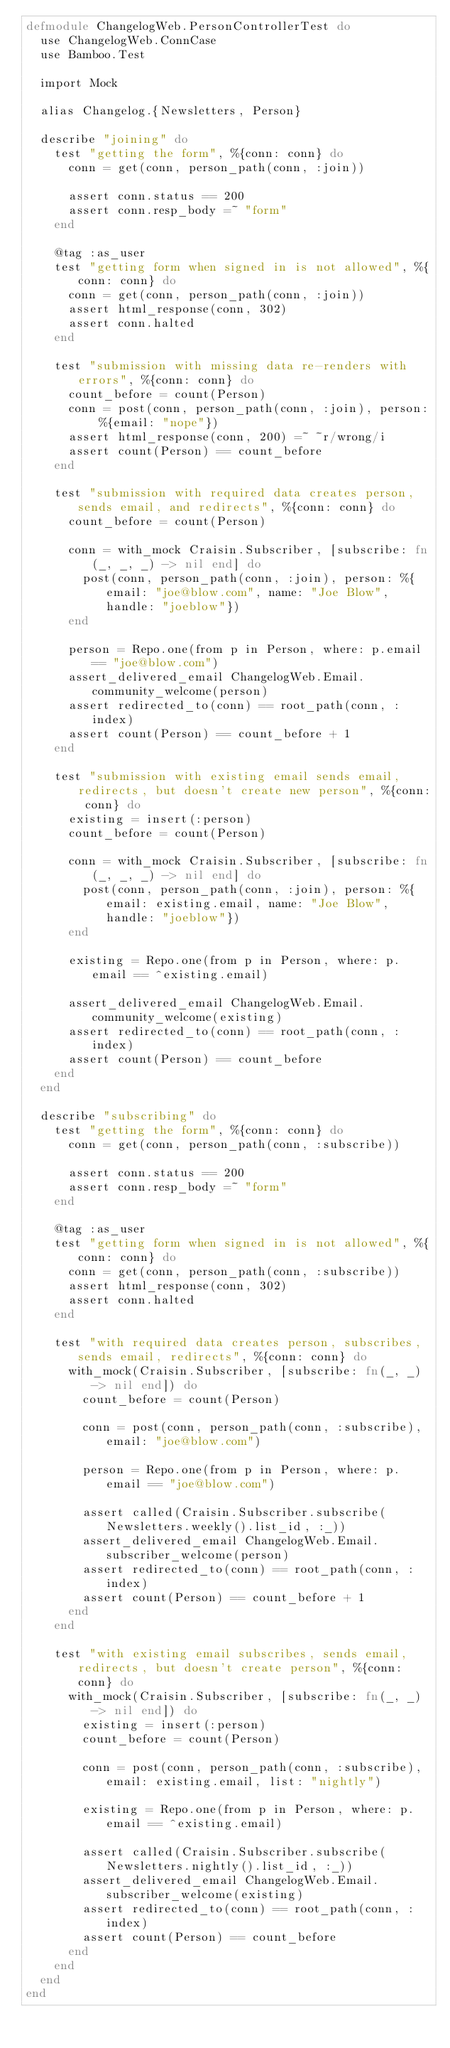<code> <loc_0><loc_0><loc_500><loc_500><_Elixir_>defmodule ChangelogWeb.PersonControllerTest do
  use ChangelogWeb.ConnCase
  use Bamboo.Test

  import Mock

  alias Changelog.{Newsletters, Person}

  describe "joining" do
    test "getting the form", %{conn: conn} do
      conn = get(conn, person_path(conn, :join))

      assert conn.status == 200
      assert conn.resp_body =~ "form"
    end

    @tag :as_user
    test "getting form when signed in is not allowed", %{conn: conn} do
      conn = get(conn, person_path(conn, :join))
      assert html_response(conn, 302)
      assert conn.halted
    end

    test "submission with missing data re-renders with errors", %{conn: conn} do
      count_before = count(Person)
      conn = post(conn, person_path(conn, :join), person: %{email: "nope"})
      assert html_response(conn, 200) =~ ~r/wrong/i
      assert count(Person) == count_before
    end

    test "submission with required data creates person, sends email, and redirects", %{conn: conn} do
      count_before = count(Person)

      conn = with_mock Craisin.Subscriber, [subscribe: fn(_, _, _) -> nil end] do
        post(conn, person_path(conn, :join), person: %{email: "joe@blow.com", name: "Joe Blow", handle: "joeblow"})
      end

      person = Repo.one(from p in Person, where: p.email == "joe@blow.com")
      assert_delivered_email ChangelogWeb.Email.community_welcome(person)
      assert redirected_to(conn) == root_path(conn, :index)
      assert count(Person) == count_before + 1
    end

    test "submission with existing email sends email, redirects, but doesn't create new person", %{conn: conn} do
      existing = insert(:person)
      count_before = count(Person)

      conn = with_mock Craisin.Subscriber, [subscribe: fn(_, _, _) -> nil end] do
        post(conn, person_path(conn, :join), person: %{email: existing.email, name: "Joe Blow", handle: "joeblow"})
      end

      existing = Repo.one(from p in Person, where: p.email == ^existing.email)

      assert_delivered_email ChangelogWeb.Email.community_welcome(existing)
      assert redirected_to(conn) == root_path(conn, :index)
      assert count(Person) == count_before
    end
  end

  describe "subscribing" do
    test "getting the form", %{conn: conn} do
      conn = get(conn, person_path(conn, :subscribe))

      assert conn.status == 200
      assert conn.resp_body =~ "form"
    end

    @tag :as_user
    test "getting form when signed in is not allowed", %{conn: conn} do
      conn = get(conn, person_path(conn, :subscribe))
      assert html_response(conn, 302)
      assert conn.halted
    end

    test "with required data creates person, subscribes, sends email, redirects", %{conn: conn} do
      with_mock(Craisin.Subscriber, [subscribe: fn(_, _) -> nil end]) do
        count_before = count(Person)

        conn = post(conn, person_path(conn, :subscribe), email: "joe@blow.com")

        person = Repo.one(from p in Person, where: p.email == "joe@blow.com")

        assert called(Craisin.Subscriber.subscribe(Newsletters.weekly().list_id, :_))
        assert_delivered_email ChangelogWeb.Email.subscriber_welcome(person)
        assert redirected_to(conn) == root_path(conn, :index)
        assert count(Person) == count_before + 1
      end
    end

    test "with existing email subscribes, sends email, redirects, but doesn't create person", %{conn: conn} do
      with_mock(Craisin.Subscriber, [subscribe: fn(_, _) -> nil end]) do
        existing = insert(:person)
        count_before = count(Person)

        conn = post(conn, person_path(conn, :subscribe), email: existing.email, list: "nightly")

        existing = Repo.one(from p in Person, where: p.email == ^existing.email)

        assert called(Craisin.Subscriber.subscribe(Newsletters.nightly().list_id, :_))
        assert_delivered_email ChangelogWeb.Email.subscriber_welcome(existing)
        assert redirected_to(conn) == root_path(conn, :index)
        assert count(Person) == count_before
      end
    end
  end
end
</code> 